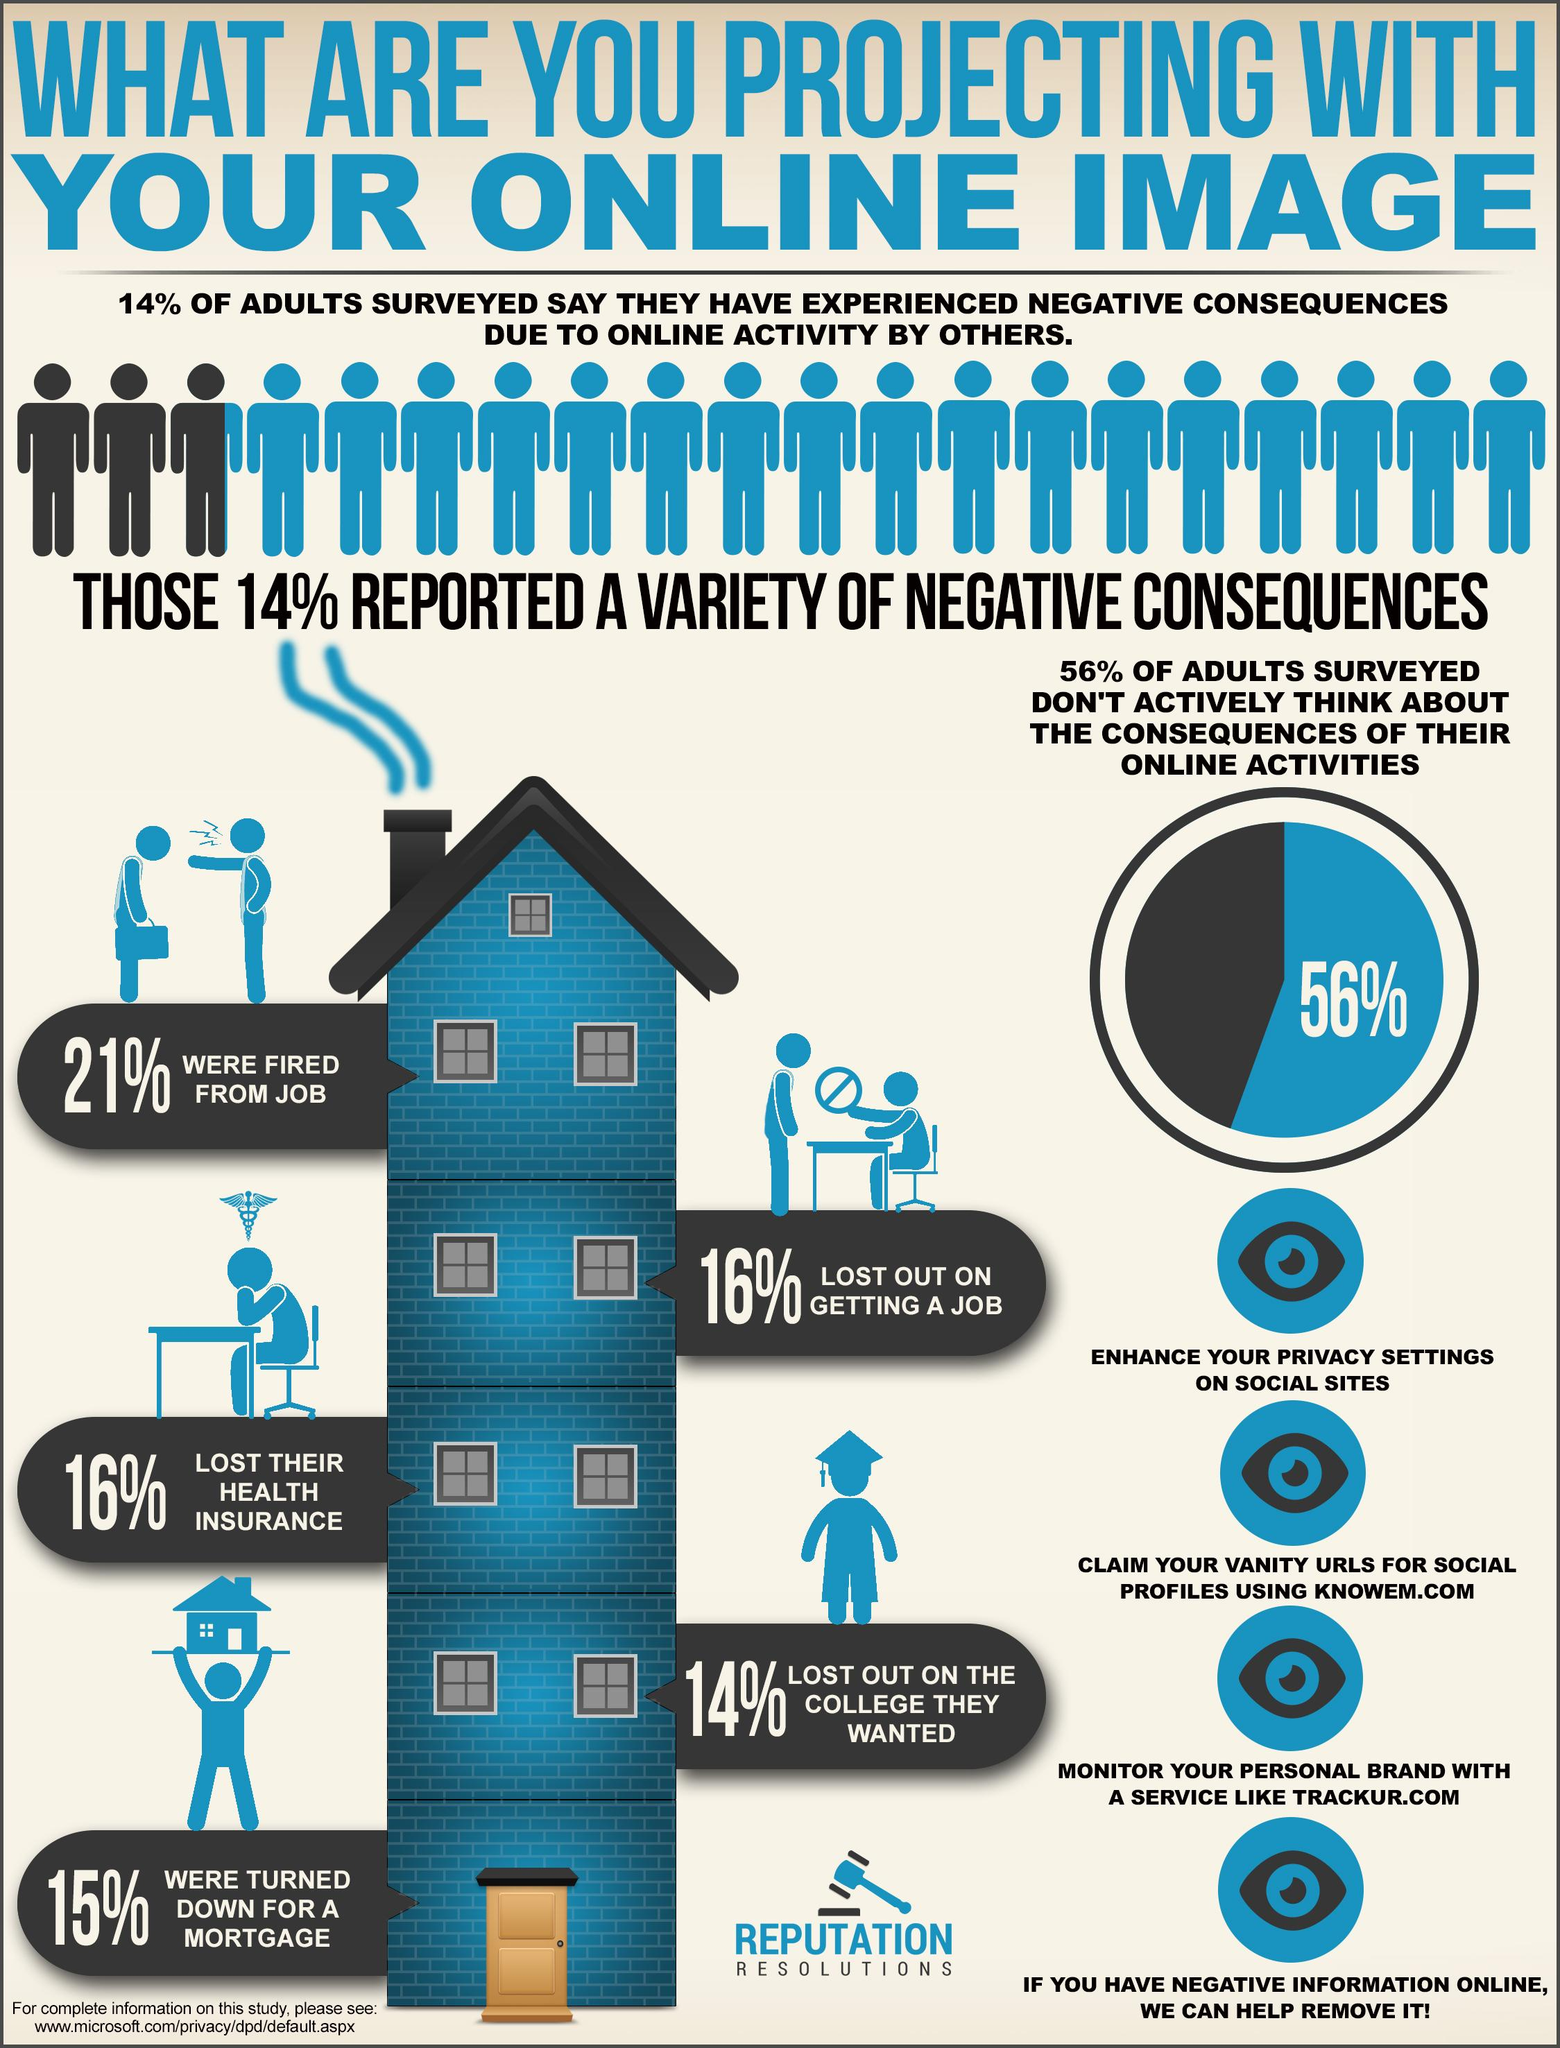Indicate a few pertinent items in this graphic. According to the given data, a significant majority of adults, approximately 86%, have not faced any negative consequences due to their online activity by others. According to a survey, 44% of adults actively consider the consequences of their online activities. 